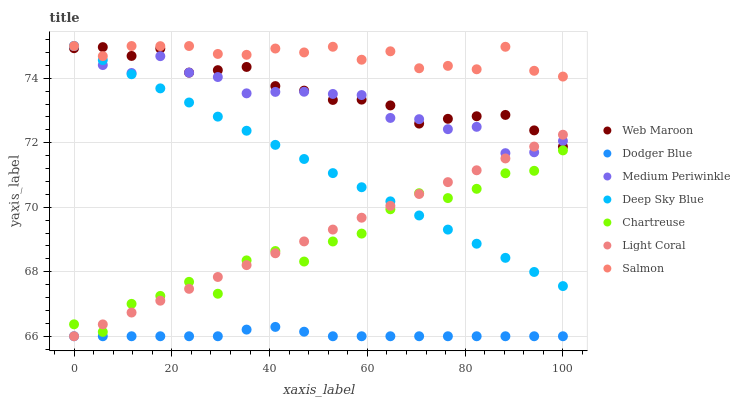Does Dodger Blue have the minimum area under the curve?
Answer yes or no. Yes. Does Salmon have the maximum area under the curve?
Answer yes or no. Yes. Does Web Maroon have the minimum area under the curve?
Answer yes or no. No. Does Web Maroon have the maximum area under the curve?
Answer yes or no. No. Is Light Coral the smoothest?
Answer yes or no. Yes. Is Chartreuse the roughest?
Answer yes or no. Yes. Is Web Maroon the smoothest?
Answer yes or no. No. Is Web Maroon the roughest?
Answer yes or no. No. Does Light Coral have the lowest value?
Answer yes or no. Yes. Does Web Maroon have the lowest value?
Answer yes or no. No. Does Salmon have the highest value?
Answer yes or no. Yes. Does Web Maroon have the highest value?
Answer yes or no. No. Is Chartreuse less than Web Maroon?
Answer yes or no. Yes. Is Salmon greater than Light Coral?
Answer yes or no. Yes. Does Light Coral intersect Deep Sky Blue?
Answer yes or no. Yes. Is Light Coral less than Deep Sky Blue?
Answer yes or no. No. Is Light Coral greater than Deep Sky Blue?
Answer yes or no. No. Does Chartreuse intersect Web Maroon?
Answer yes or no. No. 